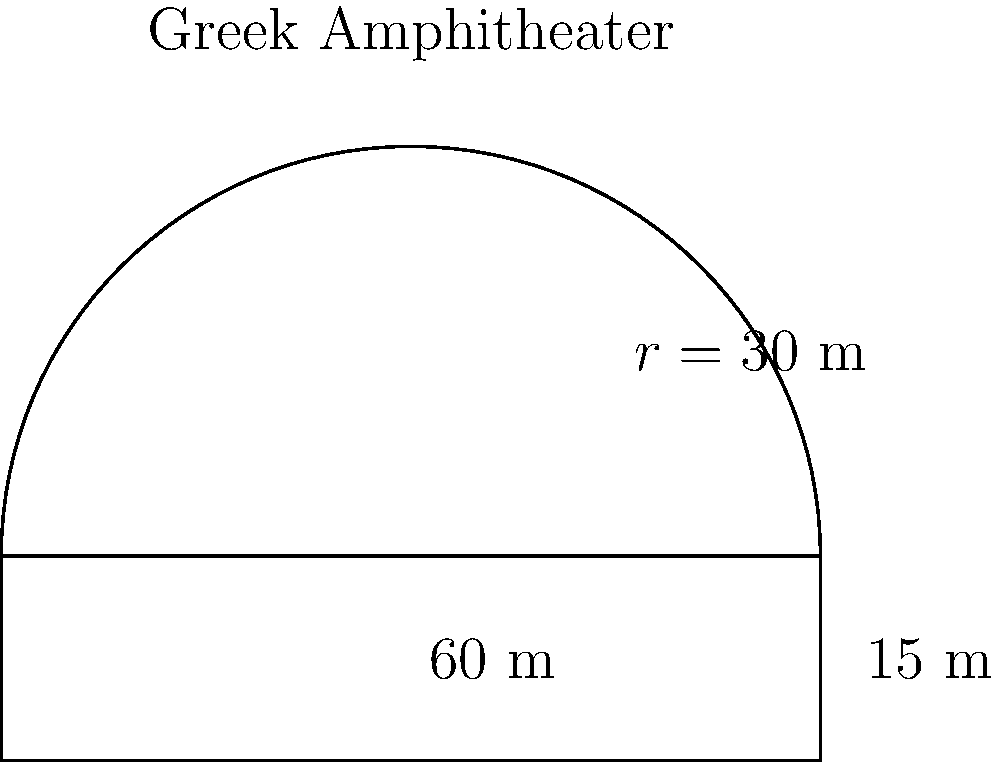A biotech conference is being held in a modern Greek-inspired amphitheater in Cambridge, Massachusetts. The amphitheater's seating area is shaped like a semicircle with a radius of 30 meters, and the stage is rectangular, extending 15 meters from the diameter of the semicircle. What is the perimeter of the entire amphitheater structure in meters? To find the perimeter of the amphitheater, we need to calculate the sum of:
1. The length of the semicircular arc
2. The width of the rectangular stage
3. The two sides of the rectangular stage

Step 1: Calculate the length of the semicircular arc
- The formula for the length of a semicircle is $\pi r$
- Arc length = $\pi \times 30 = 30\pi$ meters

Step 2: Calculate the width of the rectangular stage
- The width is equal to the diameter of the semicircle
- Width = $2r = 2 \times 30 = 60$ meters

Step 3: Calculate the length of the two sides of the rectangular stage
- Each side is 15 meters
- Total length of sides = $15 \times 2 = 30$ meters

Step 4: Sum up all the parts
Total perimeter = Arc length + Width + Sides
$$ \text{Perimeter} = 30\pi + 60 + 30 = 30\pi + 90 \text{ meters} $$

Step 5: Simplify the expression (optional)
$$ \text{Perimeter} \approx 94.25 + 90 = 184.25 \text{ meters} $$
Answer: $30\pi + 90$ meters (or approximately 184.25 meters) 